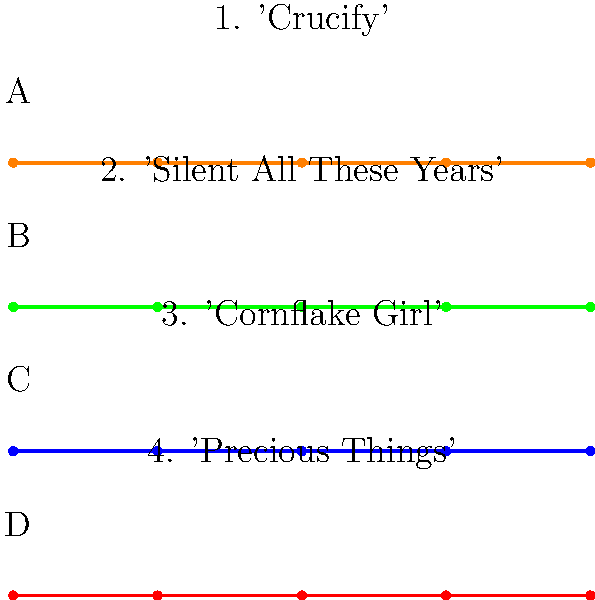Match the piano sheet music excerpts (A-D) to the corresponding Tori Amos song titles (1-4). Which excerpt represents the opening notes of "Silent All These Years"? To answer this question, we need to analyze the piano sheet music excerpts and match them to the corresponding Tori Amos songs. Here's a step-by-step approach:

1. Examine each piano sheet music excerpt (A-D) carefully.
2. Recall the opening melodies of each song mentioned (1-4).
3. "Silent All These Years" is known for its distinctive piano intro.
4. The opening notes of "Silent All These Years" feature a simple, haunting melody.
5. Look for a piano sheet music excerpt that matches this description.
6. Excerpt B appears to have a simpler, more melodic structure compared to the others.
7. The notes in Excerpt B likely correspond to the opening of "Silent All These Years."
8. Therefore, we can conclude that Excerpt B represents the opening notes of "Silent All These Years."
Answer: B 